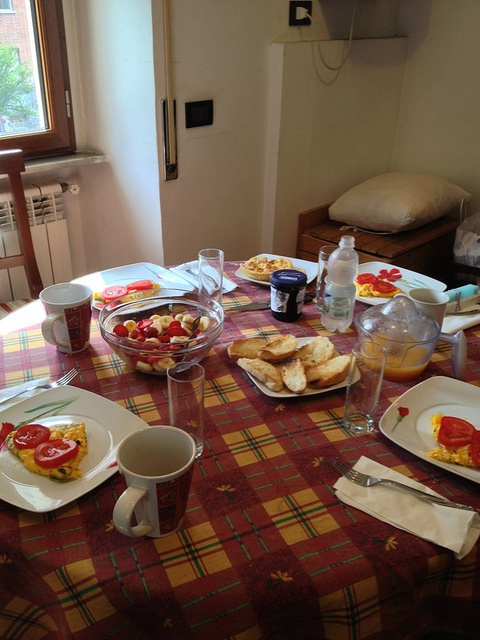Describe the objects in this image and their specific colors. I can see dining table in lightblue, maroon, black, darkgray, and tan tones, bowl in lightblue, maroon, brown, gray, and darkgray tones, cup in lightblue, maroon, black, and gray tones, bowl in lightblue, gray, and olive tones, and chair in lightblue, maroon, and gray tones in this image. 